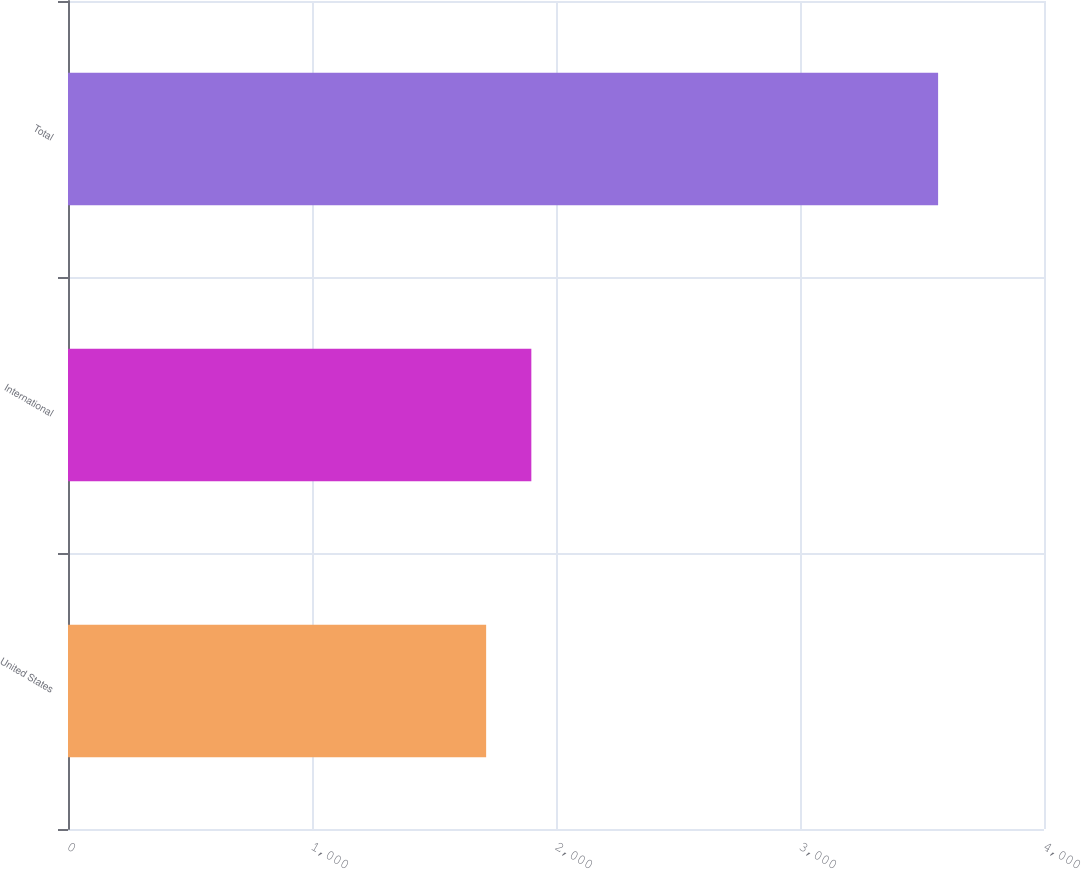<chart> <loc_0><loc_0><loc_500><loc_500><bar_chart><fcel>United States<fcel>International<fcel>Total<nl><fcel>1713.7<fcel>1898.93<fcel>3566<nl></chart> 